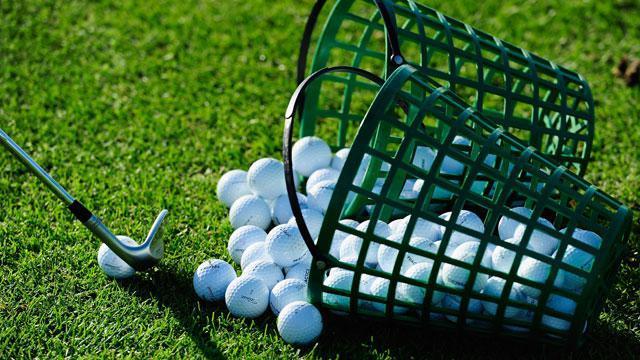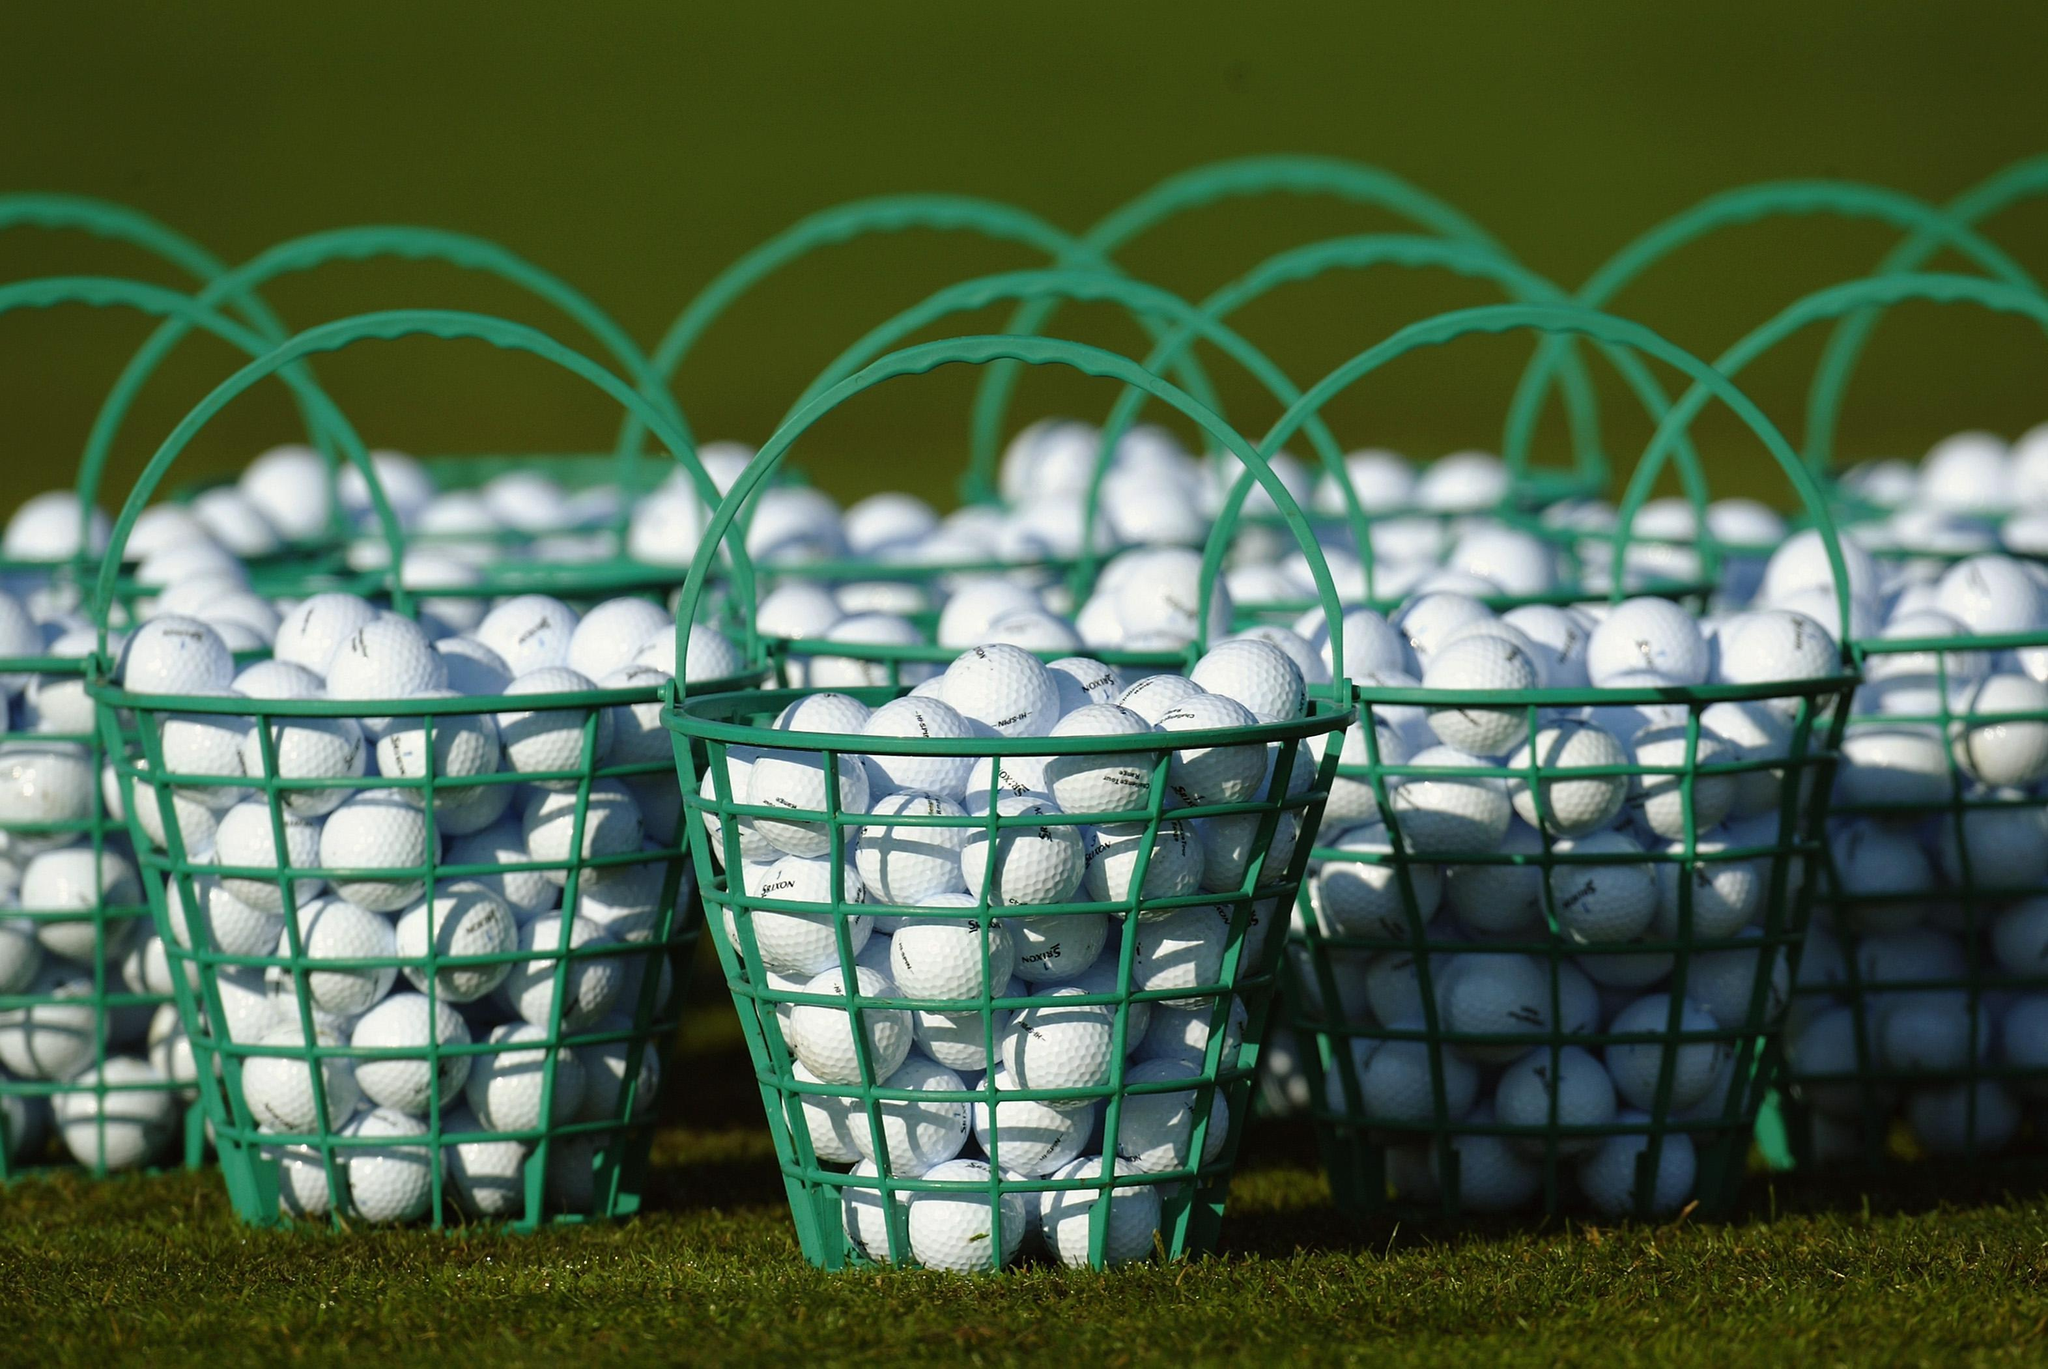The first image is the image on the left, the second image is the image on the right. Analyze the images presented: Is the assertion "There is a red golf ball in the pile." valid? Answer yes or no. No. The first image is the image on the left, the second image is the image on the right. Given the left and right images, does the statement "In 1 of the images, at least 1 bucket is tipped over." hold true? Answer yes or no. Yes. 